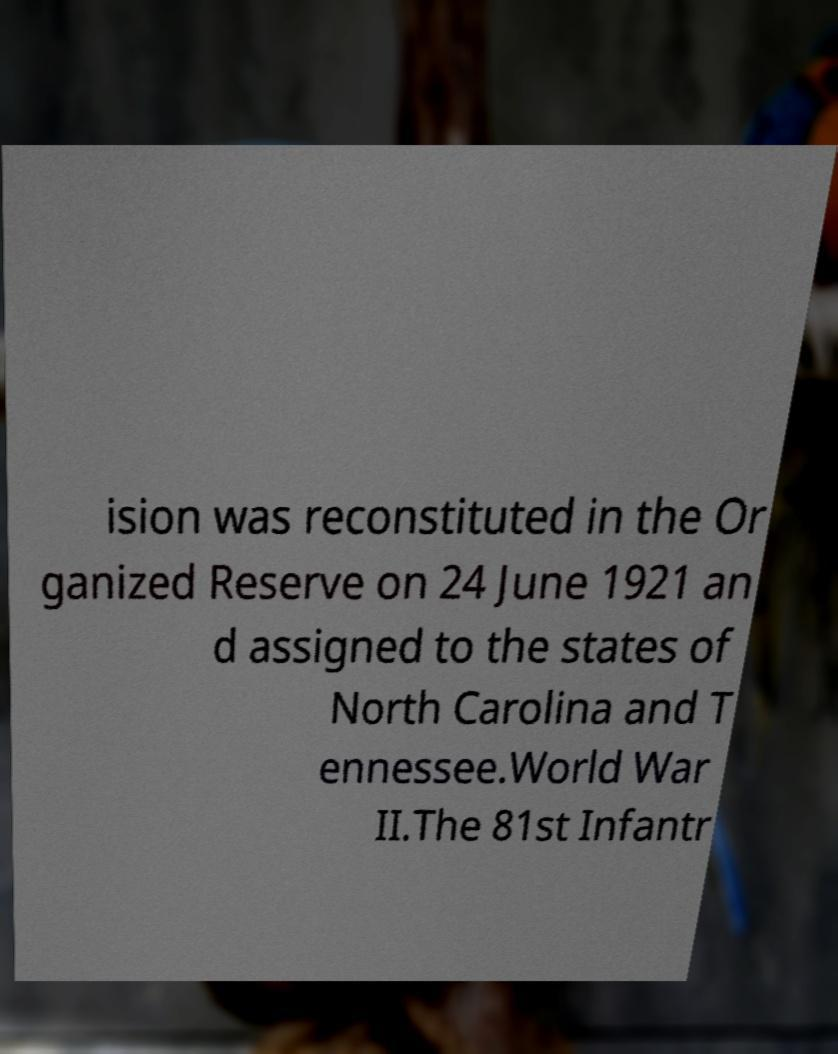Could you extract and type out the text from this image? ision was reconstituted in the Or ganized Reserve on 24 June 1921 an d assigned to the states of North Carolina and T ennessee.World War II.The 81st Infantr 